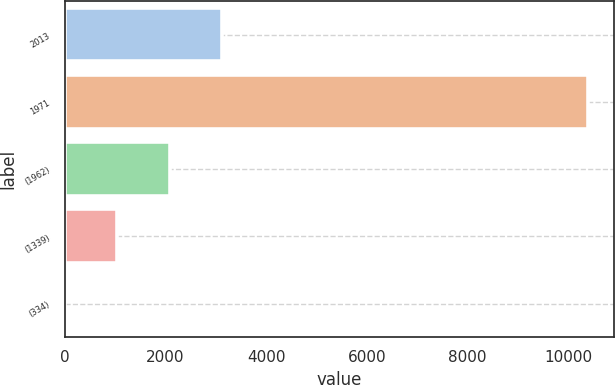<chart> <loc_0><loc_0><loc_500><loc_500><bar_chart><fcel>2013<fcel>1971<fcel>(1962)<fcel>(1339)<fcel>(334)<nl><fcel>3119.13<fcel>10397<fcel>2079.44<fcel>1039.75<fcel>0.06<nl></chart> 